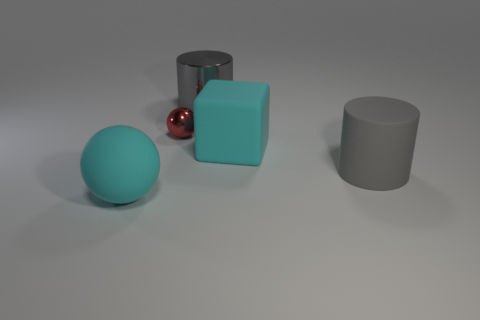The cyan rubber object in front of the gray rubber object has what shape? sphere 